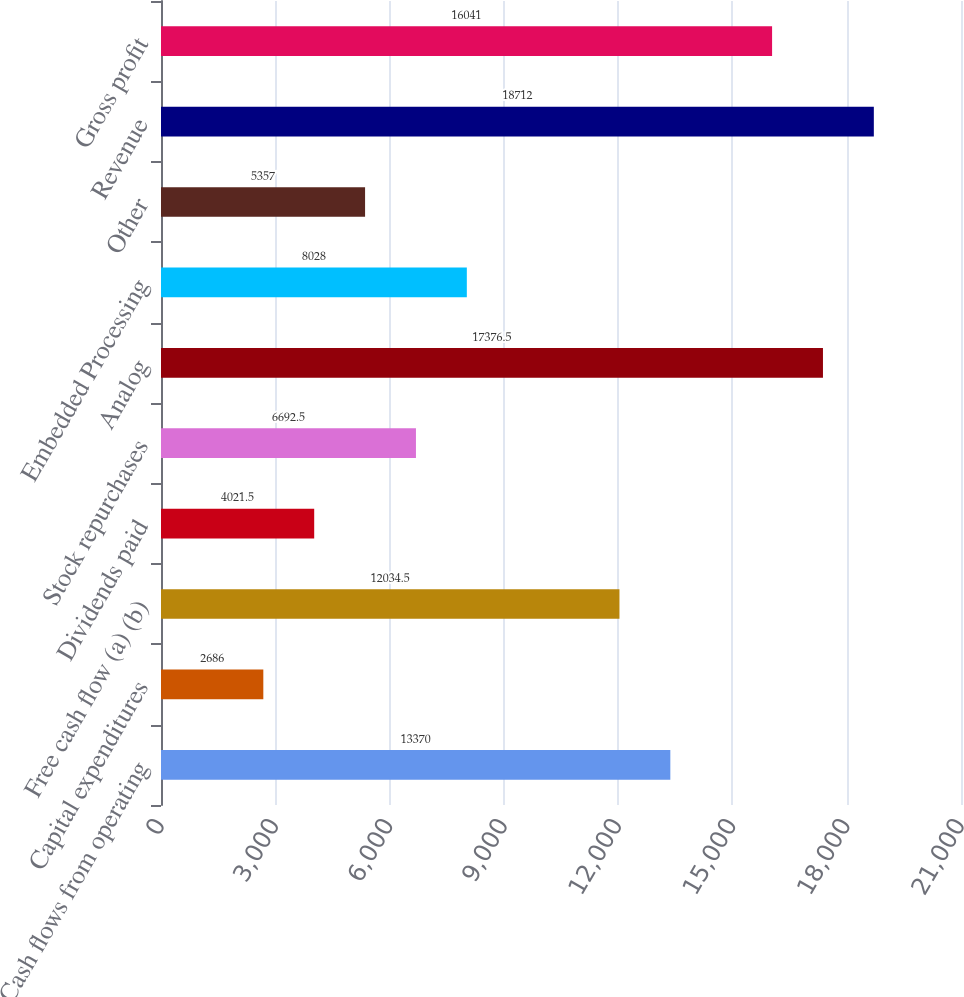Convert chart. <chart><loc_0><loc_0><loc_500><loc_500><bar_chart><fcel>Cash flows from operating<fcel>Capital expenditures<fcel>Free cash flow (a) (b)<fcel>Dividends paid<fcel>Stock repurchases<fcel>Analog<fcel>Embedded Processing<fcel>Other<fcel>Revenue<fcel>Gross profit<nl><fcel>13370<fcel>2686<fcel>12034.5<fcel>4021.5<fcel>6692.5<fcel>17376.5<fcel>8028<fcel>5357<fcel>18712<fcel>16041<nl></chart> 